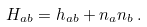<formula> <loc_0><loc_0><loc_500><loc_500>H _ { a b } = h _ { a b } + n _ { a } n _ { b } \, .</formula> 